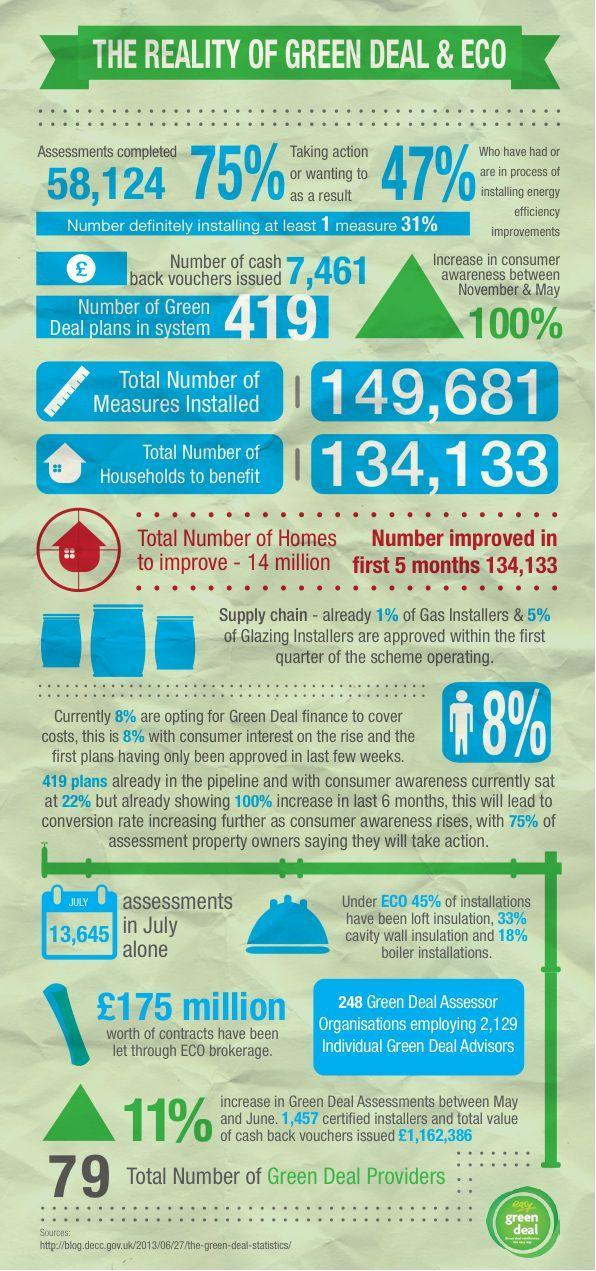What is the number of green deal assessments done in the month of July?
Answer the question with a short phrase. 13,645 What is the number of green deal assessments completed? 58,124 How many individual green deal advisors were employed by the green deal assessor organisations? 2,129 What is the percentage increase in consumer awareness about the green deal between November & May? 100% What is the number of cash back vouchers issued by the green deal organisations? 7,461 What is the number of green deal plans in the system? 419 What is the total number of households to benefit from the green deal plans? 134,133 